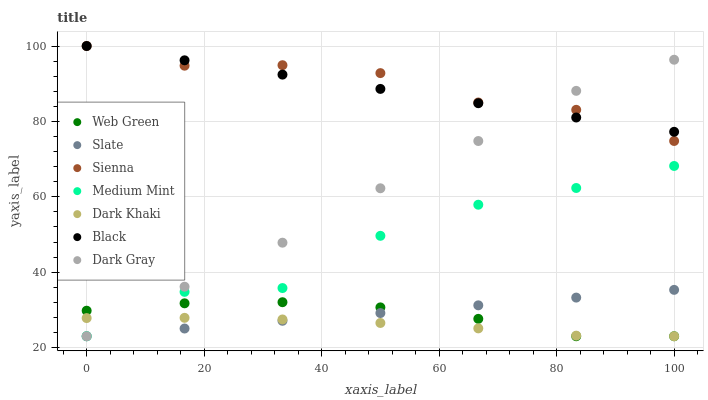Does Dark Khaki have the minimum area under the curve?
Answer yes or no. Yes. Does Sienna have the maximum area under the curve?
Answer yes or no. Yes. Does Slate have the minimum area under the curve?
Answer yes or no. No. Does Slate have the maximum area under the curve?
Answer yes or no. No. Is Slate the smoothest?
Answer yes or no. Yes. Is Medium Mint the roughest?
Answer yes or no. Yes. Is Dark Khaki the smoothest?
Answer yes or no. No. Is Dark Khaki the roughest?
Answer yes or no. No. Does Medium Mint have the lowest value?
Answer yes or no. Yes. Does Sienna have the lowest value?
Answer yes or no. No. Does Black have the highest value?
Answer yes or no. Yes. Does Slate have the highest value?
Answer yes or no. No. Is Web Green less than Sienna?
Answer yes or no. Yes. Is Black greater than Slate?
Answer yes or no. Yes. Does Dark Gray intersect Black?
Answer yes or no. Yes. Is Dark Gray less than Black?
Answer yes or no. No. Is Dark Gray greater than Black?
Answer yes or no. No. Does Web Green intersect Sienna?
Answer yes or no. No. 